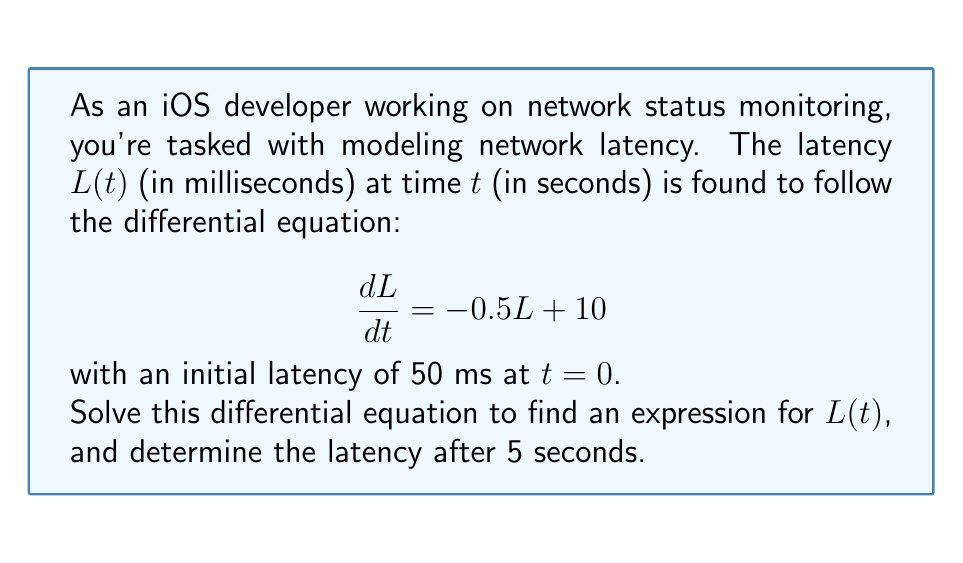Teach me how to tackle this problem. Let's solve this step-by-step:

1) We have a first-order linear differential equation:
   $$\frac{dL}{dt} = -0.5L + 10$$

2) This is in the form $\frac{dy}{dx} + P(x)y = Q(x)$, where:
   $P(x) = 0.5$ and $Q(x) = 10$

3) The integrating factor is $e^{\int P(x)dx} = e^{0.5t}$

4) Multiply both sides by the integrating factor:
   $$e^{0.5t}\frac{dL}{dt} + 0.5e^{0.5t}L = 10e^{0.5t}$$

5) The left side is now the derivative of $e^{0.5t}L$:
   $$\frac{d}{dt}(e^{0.5t}L) = 10e^{0.5t}$$

6) Integrate both sides:
   $$e^{0.5t}L = 20e^{0.5t} + C$$

7) Solve for $L$:
   $$L = 20 + Ce^{-0.5t}$$

8) Use the initial condition $L(0) = 50$ to find $C$:
   $$50 = 20 + C$$
   $$C = 30$$

9) The final solution is:
   $$L(t) = 20 + 30e^{-0.5t}$$

10) To find the latency after 5 seconds, substitute $t=5$:
    $$L(5) = 20 + 30e^{-0.5(5)} \approx 31.47$$ ms
Answer: $L(t) = 20 + 30e^{-0.5t}$; $L(5) \approx 31.47$ ms 